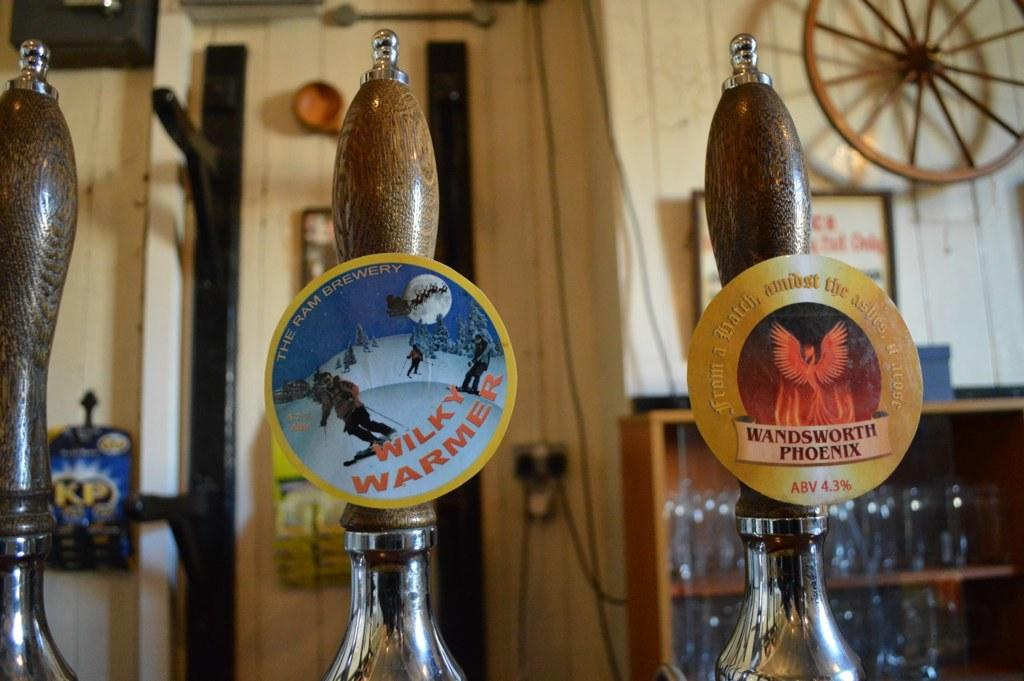Provide a one-sentence caption for the provided image. Wilky warmer and  wandsworth phoenix labels on a bottle. 